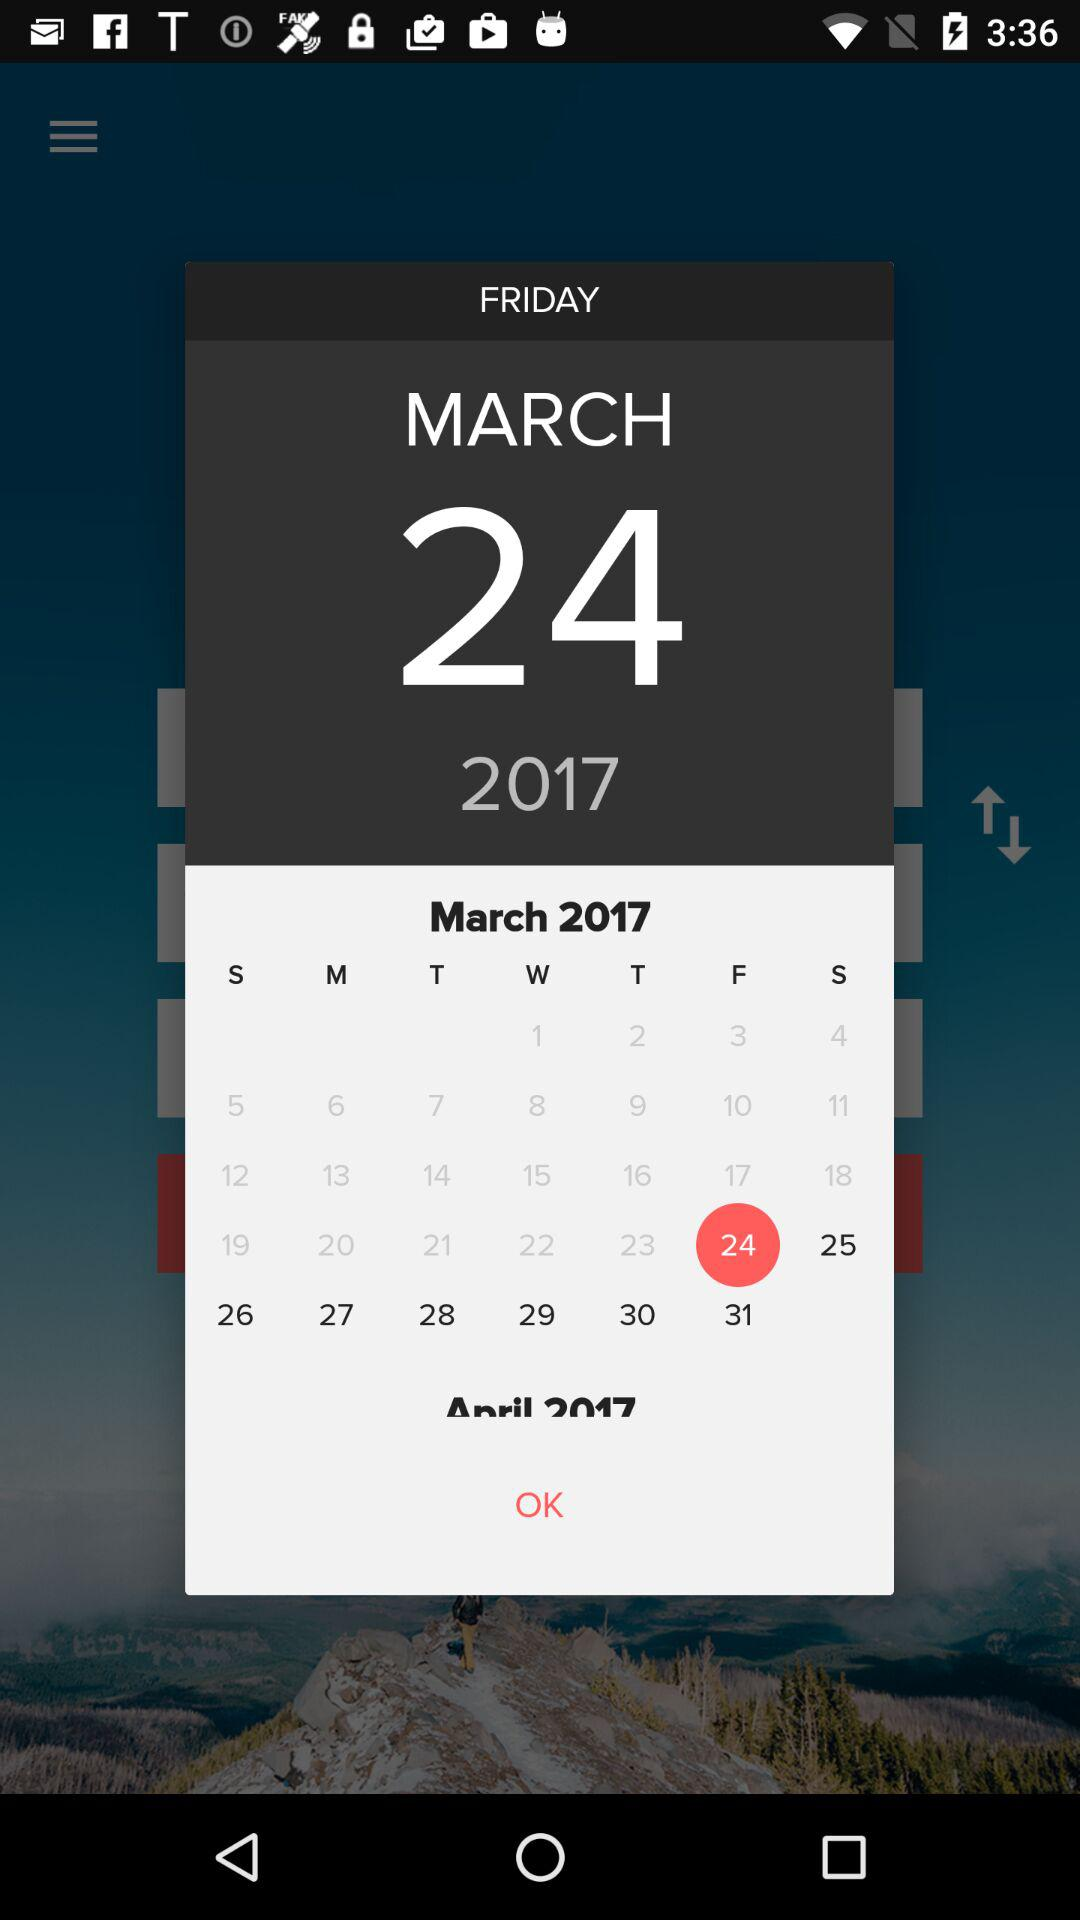What is the day on the 24th March 2017? The day is "Friday". 